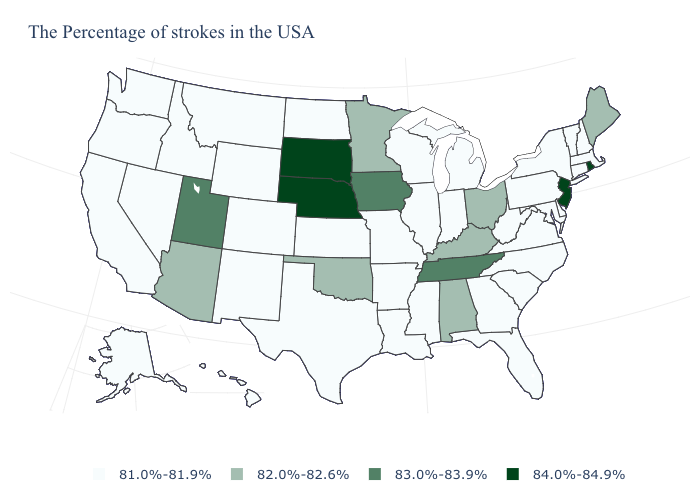What is the value of Oklahoma?
Answer briefly. 82.0%-82.6%. What is the lowest value in states that border Maine?
Give a very brief answer. 81.0%-81.9%. What is the highest value in states that border South Carolina?
Keep it brief. 81.0%-81.9%. What is the value of Alabama?
Keep it brief. 82.0%-82.6%. What is the value of New Mexico?
Give a very brief answer. 81.0%-81.9%. Does the first symbol in the legend represent the smallest category?
Keep it brief. Yes. What is the lowest value in the South?
Be succinct. 81.0%-81.9%. What is the value of Washington?
Give a very brief answer. 81.0%-81.9%. What is the highest value in states that border Iowa?
Be succinct. 84.0%-84.9%. How many symbols are there in the legend?
Answer briefly. 4. Name the states that have a value in the range 81.0%-81.9%?
Give a very brief answer. Massachusetts, New Hampshire, Vermont, Connecticut, New York, Delaware, Maryland, Pennsylvania, Virginia, North Carolina, South Carolina, West Virginia, Florida, Georgia, Michigan, Indiana, Wisconsin, Illinois, Mississippi, Louisiana, Missouri, Arkansas, Kansas, Texas, North Dakota, Wyoming, Colorado, New Mexico, Montana, Idaho, Nevada, California, Washington, Oregon, Alaska, Hawaii. How many symbols are there in the legend?
Be succinct. 4. What is the highest value in the USA?
Keep it brief. 84.0%-84.9%. What is the lowest value in states that border Delaware?
Answer briefly. 81.0%-81.9%. 